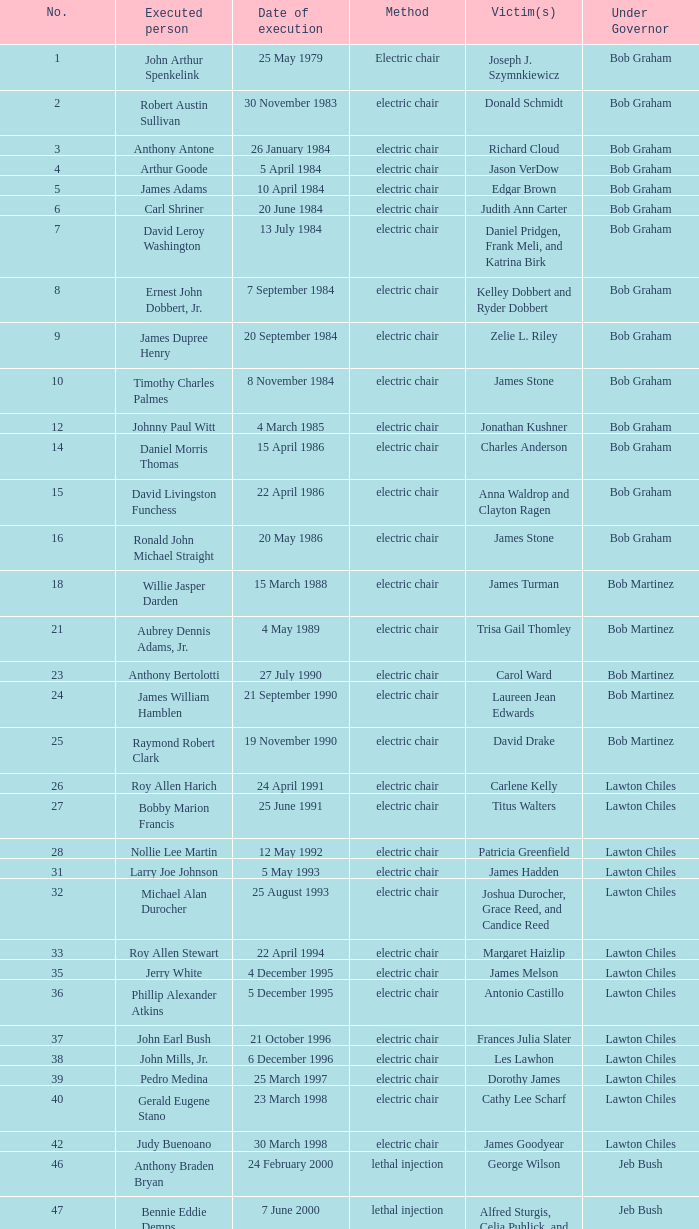Who did linroy bottoson target as his victim? Catherine Alexander. 